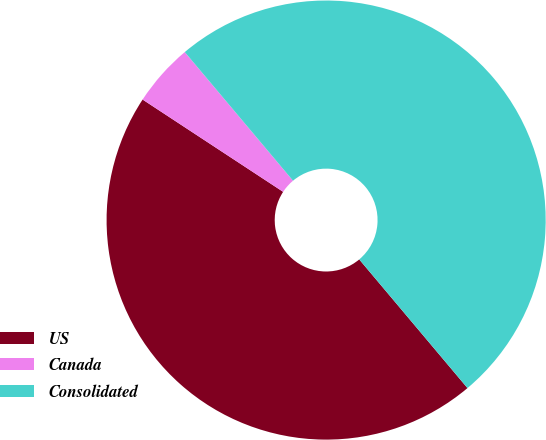Convert chart to OTSL. <chart><loc_0><loc_0><loc_500><loc_500><pie_chart><fcel>US<fcel>Canada<fcel>Consolidated<nl><fcel>45.38%<fcel>4.62%<fcel>50.0%<nl></chart> 